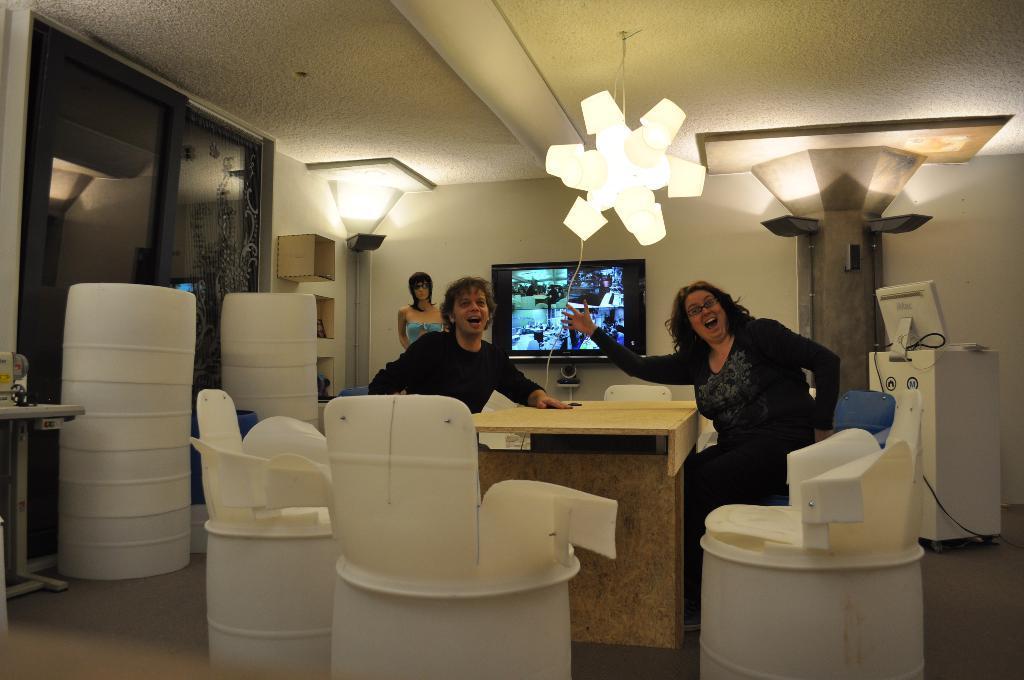How would you summarize this image in a sentence or two? In this image we can see one woman and man are sitting. In front of them, table is present. At the bottom of the image, we can see the chairs. In the background, we can see mannequin, monitor, wall, white color object, door and machines. At the top of the image, we can see the roof and lights. 